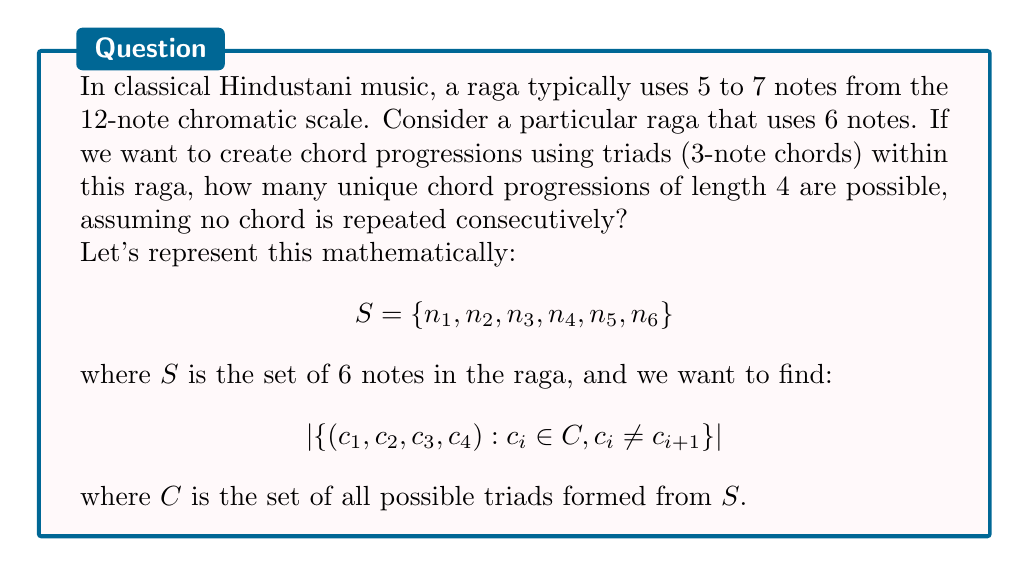Give your solution to this math problem. Let's approach this step-by-step:

1) First, we need to calculate the number of possible triads (3-note chords) from 6 notes:
   $$|C| = \binom{6}{3} = \frac{6!}{3!(6-3)!} = 20$$

2) Now, we're creating a sequence of 4 chords where no chord is repeated consecutively. This can be modeled as a permutation with restrictions.

3) For the first chord, we have 20 choices.

4) For each subsequent chord, we have 19 choices (all chords except the one just used).

5) This forms a permutation group with restrictions. The number of possibilities is:
   $$20 \times 19 \times 19 \times 19$$

6) This is because:
   - We have 20 choices for the first chord
   - For each of the next 3 positions, we have 19 choices (avoiding the chord just used)

7) Calculate the final result:
   $$20 \times 19^3 = 20 \times 6859 = 137,180$$

Thus, there are 137,180 unique chord progressions possible under these conditions.
Answer: 137,180 